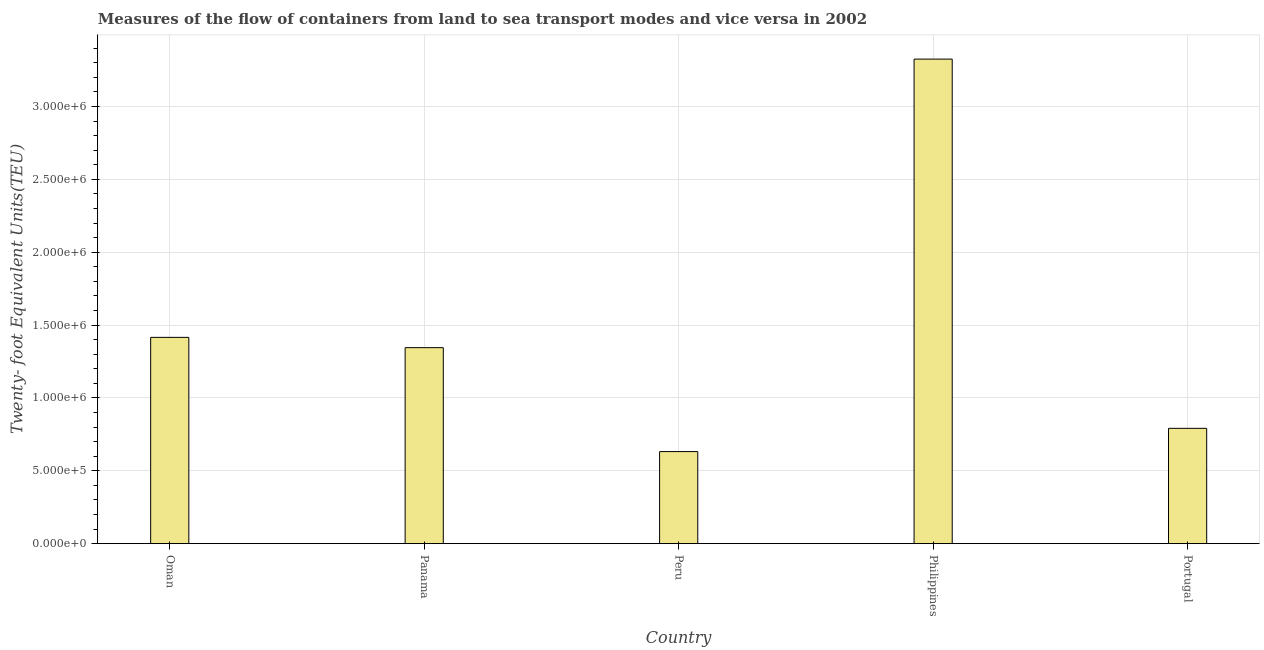What is the title of the graph?
Provide a succinct answer. Measures of the flow of containers from land to sea transport modes and vice versa in 2002. What is the label or title of the X-axis?
Keep it short and to the point. Country. What is the label or title of the Y-axis?
Provide a succinct answer. Twenty- foot Equivalent Units(TEU). What is the container port traffic in Portugal?
Keep it short and to the point. 7.91e+05. Across all countries, what is the maximum container port traffic?
Make the answer very short. 3.32e+06. Across all countries, what is the minimum container port traffic?
Keep it short and to the point. 6.32e+05. In which country was the container port traffic minimum?
Your answer should be very brief. Peru. What is the sum of the container port traffic?
Offer a terse response. 7.51e+06. What is the difference between the container port traffic in Oman and Panama?
Offer a very short reply. 7.07e+04. What is the average container port traffic per country?
Offer a very short reply. 1.50e+06. What is the median container port traffic?
Provide a short and direct response. 1.34e+06. What is the ratio of the container port traffic in Oman to that in Portugal?
Offer a very short reply. 1.79. Is the container port traffic in Oman less than that in Peru?
Keep it short and to the point. No. Is the difference between the container port traffic in Panama and Peru greater than the difference between any two countries?
Provide a short and direct response. No. What is the difference between the highest and the second highest container port traffic?
Your answer should be very brief. 1.91e+06. Is the sum of the container port traffic in Panama and Peru greater than the maximum container port traffic across all countries?
Make the answer very short. No. What is the difference between the highest and the lowest container port traffic?
Provide a succinct answer. 2.69e+06. How many bars are there?
Ensure brevity in your answer.  5. How many countries are there in the graph?
Your response must be concise. 5. What is the Twenty- foot Equivalent Units(TEU) in Oman?
Your answer should be very brief. 1.42e+06. What is the Twenty- foot Equivalent Units(TEU) in Panama?
Make the answer very short. 1.34e+06. What is the Twenty- foot Equivalent Units(TEU) in Peru?
Provide a succinct answer. 6.32e+05. What is the Twenty- foot Equivalent Units(TEU) in Philippines?
Provide a short and direct response. 3.32e+06. What is the Twenty- foot Equivalent Units(TEU) of Portugal?
Make the answer very short. 7.91e+05. What is the difference between the Twenty- foot Equivalent Units(TEU) in Oman and Panama?
Keep it short and to the point. 7.07e+04. What is the difference between the Twenty- foot Equivalent Units(TEU) in Oman and Peru?
Offer a terse response. 7.84e+05. What is the difference between the Twenty- foot Equivalent Units(TEU) in Oman and Philippines?
Provide a short and direct response. -1.91e+06. What is the difference between the Twenty- foot Equivalent Units(TEU) in Oman and Portugal?
Your answer should be compact. 6.24e+05. What is the difference between the Twenty- foot Equivalent Units(TEU) in Panama and Peru?
Keep it short and to the point. 7.13e+05. What is the difference between the Twenty- foot Equivalent Units(TEU) in Panama and Philippines?
Ensure brevity in your answer.  -1.98e+06. What is the difference between the Twenty- foot Equivalent Units(TEU) in Panama and Portugal?
Make the answer very short. 5.53e+05. What is the difference between the Twenty- foot Equivalent Units(TEU) in Peru and Philippines?
Keep it short and to the point. -2.69e+06. What is the difference between the Twenty- foot Equivalent Units(TEU) in Peru and Portugal?
Your response must be concise. -1.60e+05. What is the difference between the Twenty- foot Equivalent Units(TEU) in Philippines and Portugal?
Keep it short and to the point. 2.53e+06. What is the ratio of the Twenty- foot Equivalent Units(TEU) in Oman to that in Panama?
Your response must be concise. 1.05. What is the ratio of the Twenty- foot Equivalent Units(TEU) in Oman to that in Peru?
Provide a succinct answer. 2.24. What is the ratio of the Twenty- foot Equivalent Units(TEU) in Oman to that in Philippines?
Make the answer very short. 0.43. What is the ratio of the Twenty- foot Equivalent Units(TEU) in Oman to that in Portugal?
Provide a succinct answer. 1.79. What is the ratio of the Twenty- foot Equivalent Units(TEU) in Panama to that in Peru?
Ensure brevity in your answer.  2.13. What is the ratio of the Twenty- foot Equivalent Units(TEU) in Panama to that in Philippines?
Offer a terse response. 0.4. What is the ratio of the Twenty- foot Equivalent Units(TEU) in Panama to that in Portugal?
Ensure brevity in your answer.  1.7. What is the ratio of the Twenty- foot Equivalent Units(TEU) in Peru to that in Philippines?
Keep it short and to the point. 0.19. What is the ratio of the Twenty- foot Equivalent Units(TEU) in Peru to that in Portugal?
Your answer should be compact. 0.8. What is the ratio of the Twenty- foot Equivalent Units(TEU) in Philippines to that in Portugal?
Your answer should be very brief. 4.2. 